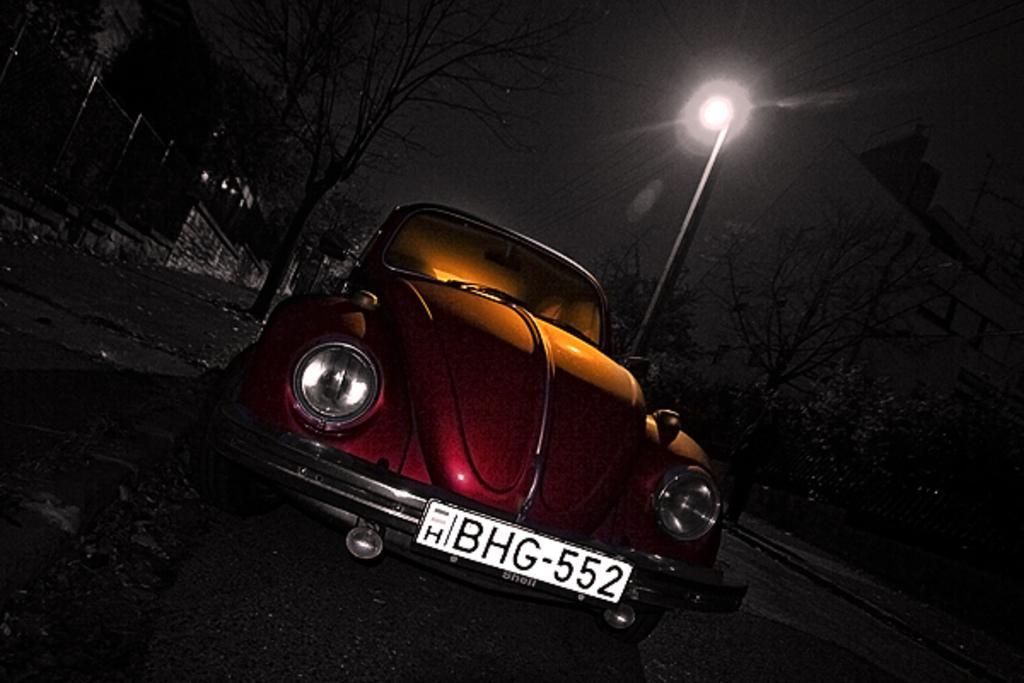Describe this image in one or two sentences. In this image in the front there is a car with some text and numbers written on it. In the background there are trees, there is a light pole, there is a fence and there are buildings. 